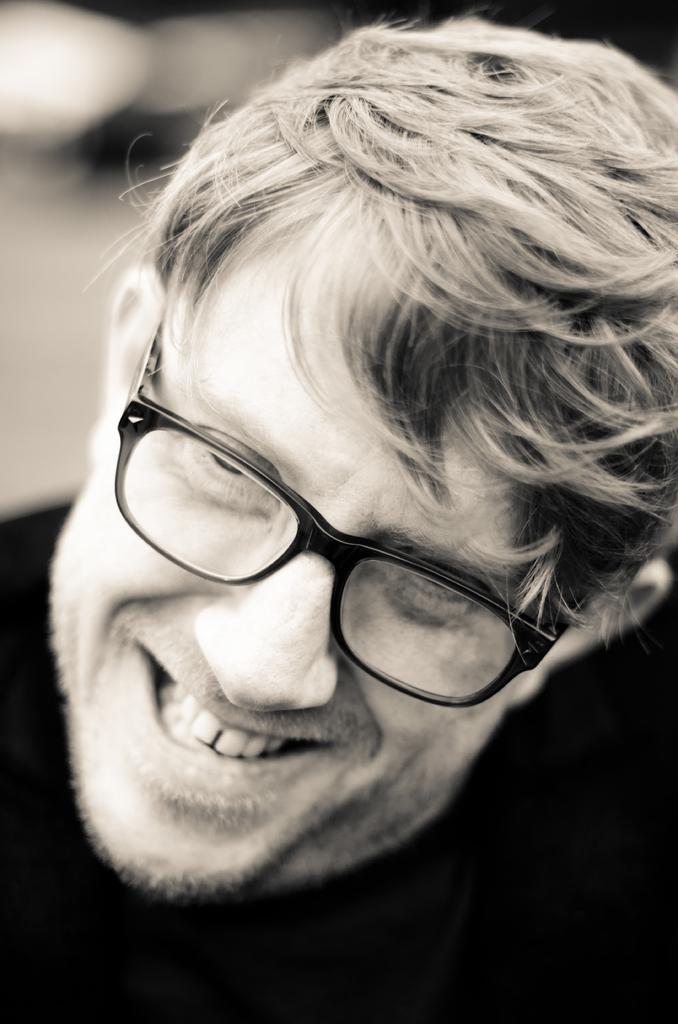In one or two sentences, can you explain what this image depicts? In this picture we can see a person smiling. Background is blurry. 